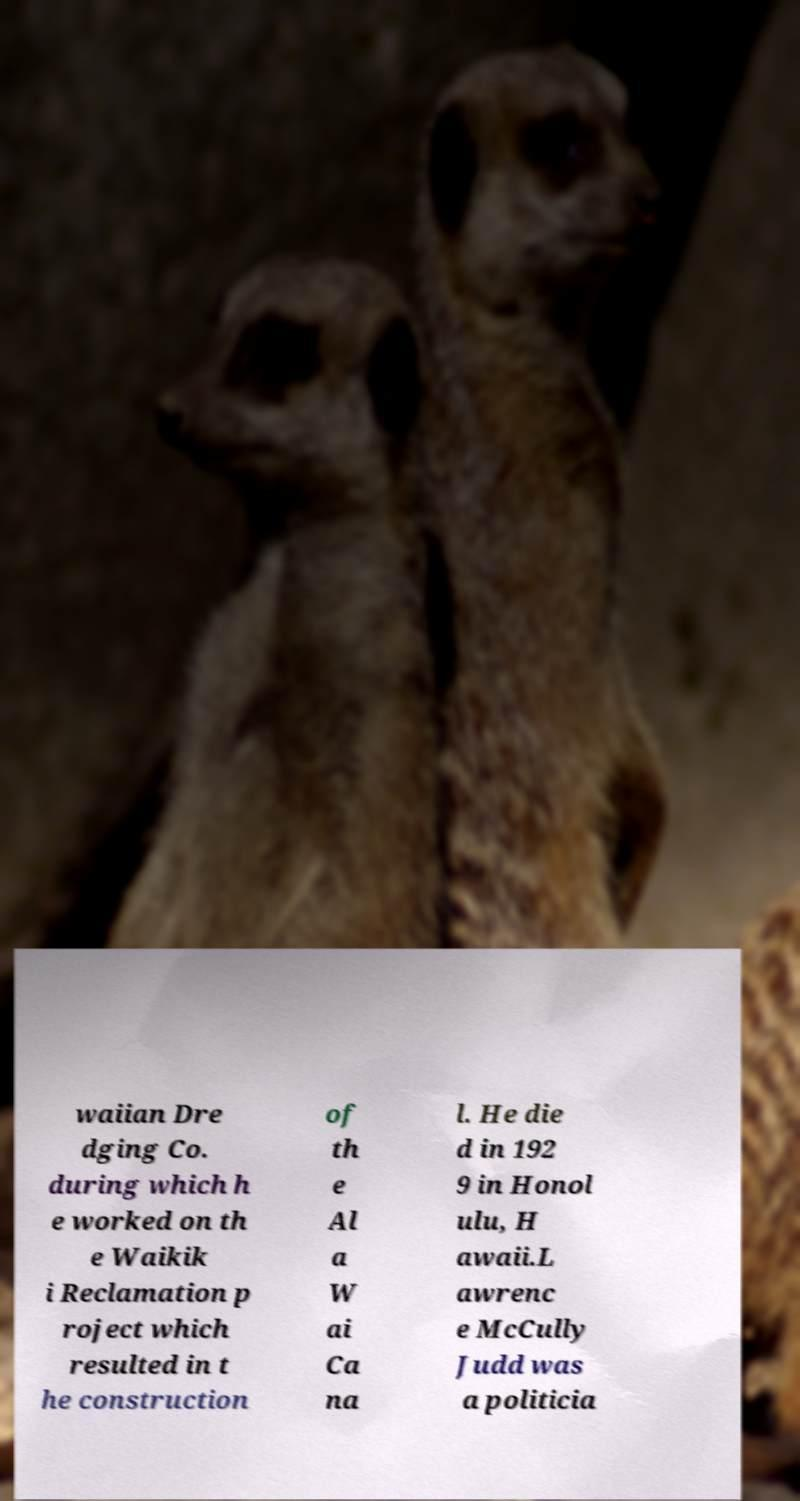What messages or text are displayed in this image? I need them in a readable, typed format. waiian Dre dging Co. during which h e worked on th e Waikik i Reclamation p roject which resulted in t he construction of th e Al a W ai Ca na l. He die d in 192 9 in Honol ulu, H awaii.L awrenc e McCully Judd was a politicia 